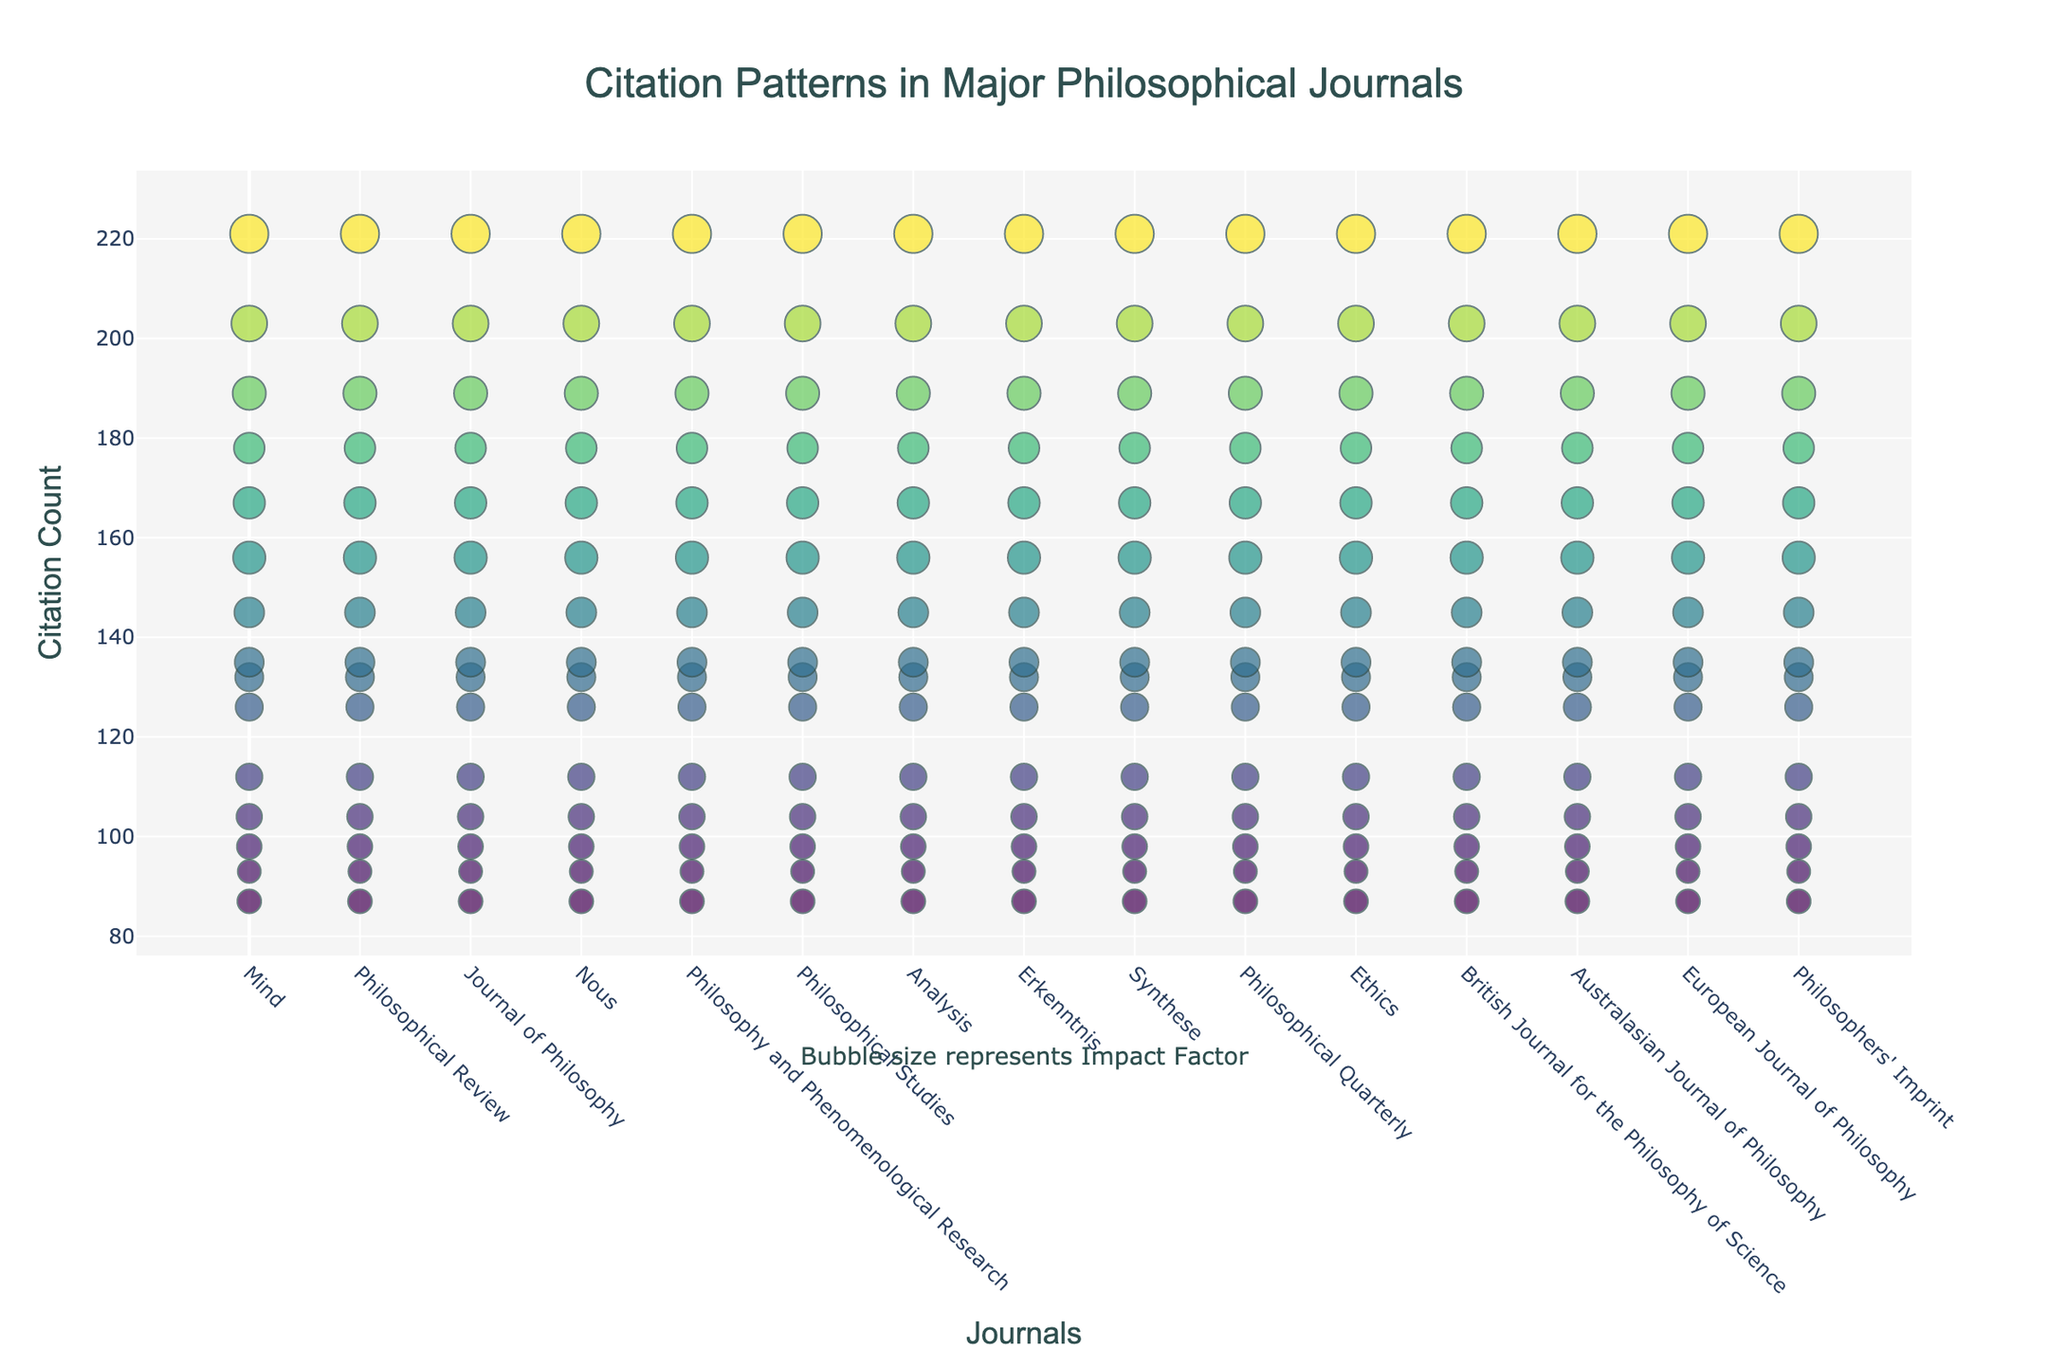What are the journals listed on the x-axis? The x-axis shows the names of the journals in tick marks. Just reading through these tick marks, one can identify the names of all the journals listed.
Answer: Mind, Philosophical Review, Journal of Philosophy, Nous, Philosophy and Phenomenological Research, Philosophical Studies, Analysis, Erkenntnis, Synthese, Philosophical Quarterly, Ethics, British Journal for the Philosophy of Science, Australasian Journal of Philosophy, European Journal of Philosophy, Philosophers' Imprint Which paper has the highest citation count? To find the paper with the highest citation count, look for the dot that is vertically the highest on the y-axis, which represents citation count. Hovering over the dots, the highest count belongs to the paper from the "Ethics" journal.
Answer: Ethics (Paper ID: 11) What is the maximum citation count, and which journal does it belong to? By identifying the highest point on the y-axis (citation count), and checking the hover information, you find the count belonging to the "Ethics" journal.
Answer: 221, Ethics What is the average impact factor of all journals? Sum up the impact factors of all the journals and then divide by the number of journals: (3.8 + 4.2 + 3.6 + 3.5 + 3.9 + 3.3 + 2.9 + 3.1 + 3.7 + 3.0 + 4.5 + 3.4 + 2.8 + 2.7 + 3.2) / 15 = 3.4
Answer: 3.4 Which journal has the smallest bubble size, and what does it represent? The smallest bubble size visually corresponds to a lower impact factor. Looking at the bubble sizes, "European Journal of Philosophy" has the smallest bubble size.
Answer: European Journal of Philosophy Compare citation counts of "Mind" and "Nous". Which journal has more citations? By comparing the y-values of the dots for "Mind" and "Nous", you can see that "Mind" has a higher citation count.
Answer: Mind (156) > Nous (145) What range does the citation count generally fall within? By observing the y-axis and the spread of the data points, most citations fall within a certain range.
Answer: 87 to 221 Which journal has the highest impact factor, and how does it affect the bubble size? By checking the size of the biggest bubble and matching it with the hover information, "Ethics" has the highest impact factor and the biggest bubble size.
Answer: Ethics (Impact Factor: 4.5) How many papers have a citation count above 200? Identifying the data points that have citation counts above the 200 mark (y-axis) and counting them reveals there are a few.
Answer: 2 (Ethics, Philosophical Review) Between "Philosophical Studies" and "British Journal for the Philosophy of Science", which has a higher citation count, and by how much? "Philosophical Studies" has a citation count of 132, while "British Journal for the Philosophy of Science" has 135. Subtract the smaller from the larger to get the difference.
Answer: British Journal for the Philosophy of Science by 3 